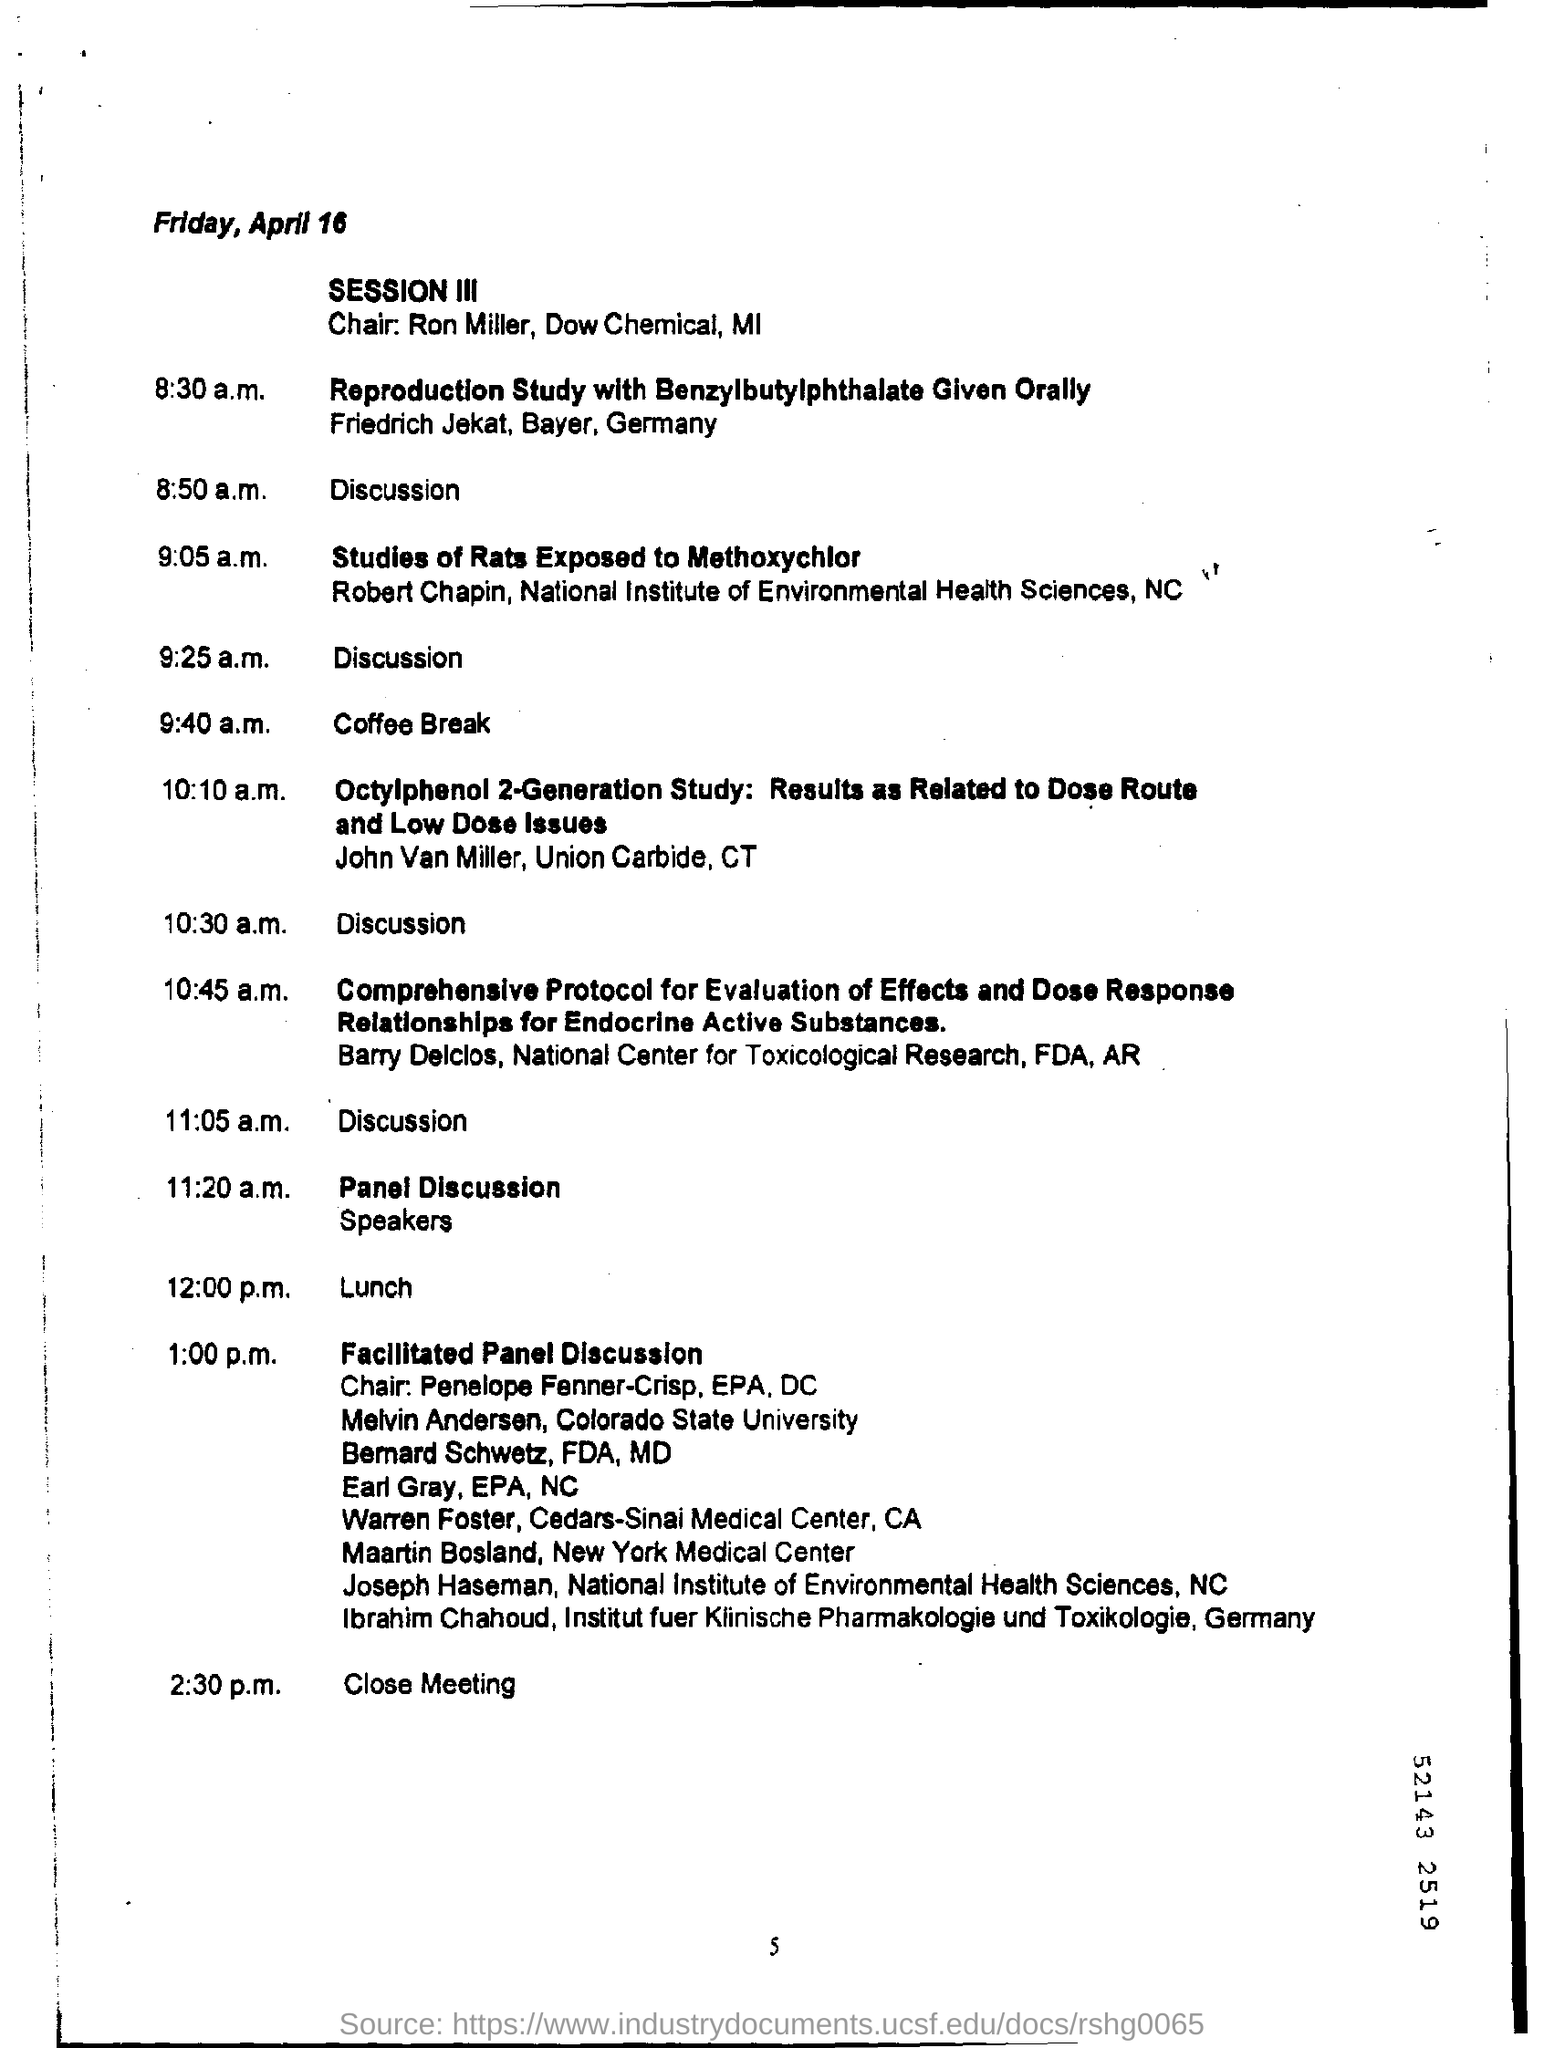Highlight a few significant elements in this photo. On April 16, Friday will occur. The coffee break is scheduled for 9:40 a.m. 